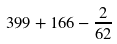Convert formula to latex. <formula><loc_0><loc_0><loc_500><loc_500>3 9 9 + 1 6 6 - \frac { 2 } { 6 2 }</formula> 